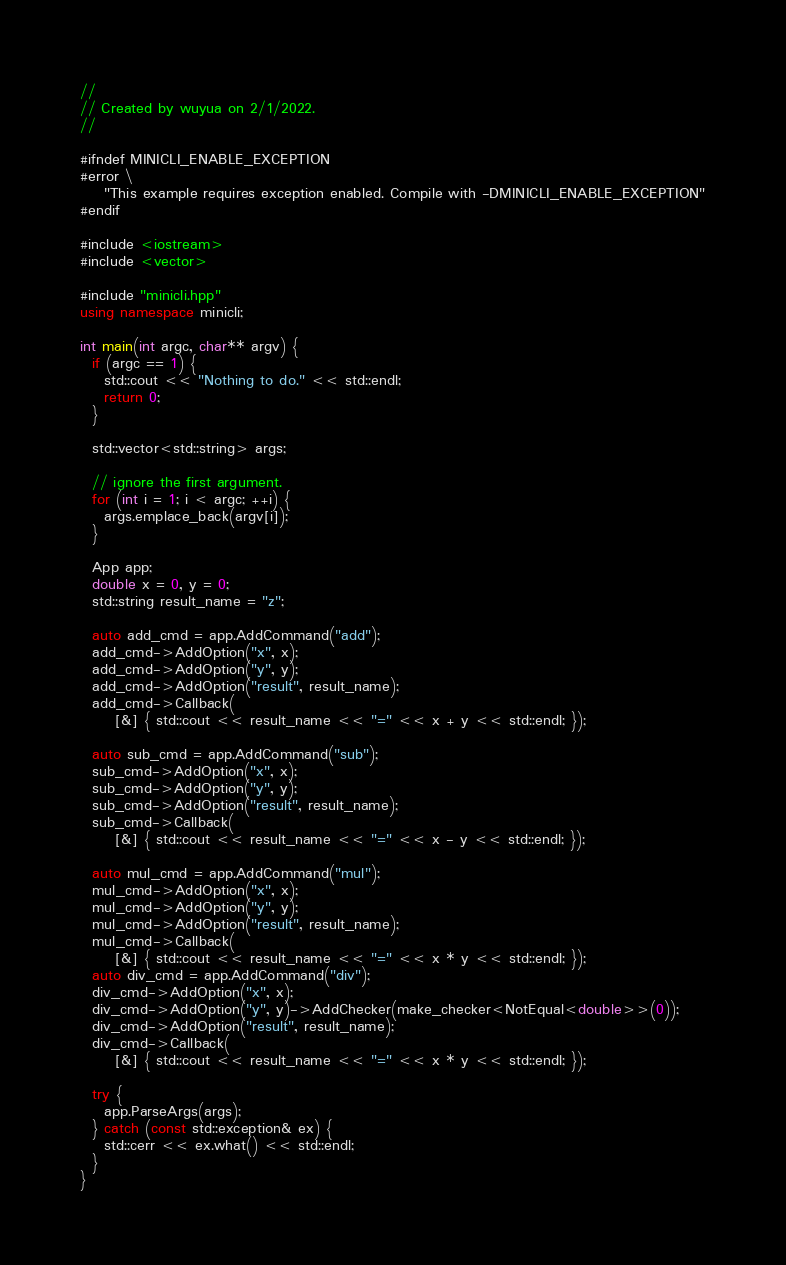<code> <loc_0><loc_0><loc_500><loc_500><_C++_>//
// Created by wuyua on 2/1/2022.
//

#ifndef MINICLI_ENABLE_EXCEPTION
#error \
    "This example requires exception enabled. Compile with -DMINICLI_ENABLE_EXCEPTION"
#endif

#include <iostream>
#include <vector>

#include "minicli.hpp"
using namespace minicli;

int main(int argc, char** argv) {
  if (argc == 1) {
    std::cout << "Nothing to do." << std::endl;
    return 0;
  }

  std::vector<std::string> args;

  // ignore the first argument.
  for (int i = 1; i < argc; ++i) {
    args.emplace_back(argv[i]);
  }

  App app;
  double x = 0, y = 0;
  std::string result_name = "z";

  auto add_cmd = app.AddCommand("add");
  add_cmd->AddOption("x", x);
  add_cmd->AddOption("y", y);
  add_cmd->AddOption("result", result_name);
  add_cmd->Callback(
      [&] { std::cout << result_name << "=" << x + y << std::endl; });

  auto sub_cmd = app.AddCommand("sub");
  sub_cmd->AddOption("x", x);
  sub_cmd->AddOption("y", y);
  sub_cmd->AddOption("result", result_name);
  sub_cmd->Callback(
      [&] { std::cout << result_name << "=" << x - y << std::endl; });

  auto mul_cmd = app.AddCommand("mul");
  mul_cmd->AddOption("x", x);
  mul_cmd->AddOption("y", y);
  mul_cmd->AddOption("result", result_name);
  mul_cmd->Callback(
      [&] { std::cout << result_name << "=" << x * y << std::endl; });
  auto div_cmd = app.AddCommand("div");
  div_cmd->AddOption("x", x);
  div_cmd->AddOption("y", y)->AddChecker(make_checker<NotEqual<double>>(0));
  div_cmd->AddOption("result", result_name);
  div_cmd->Callback(
      [&] { std::cout << result_name << "=" << x * y << std::endl; });

  try {
    app.ParseArgs(args);
  } catch (const std::exception& ex) {
    std::cerr << ex.what() << std::endl;
  }
}</code> 